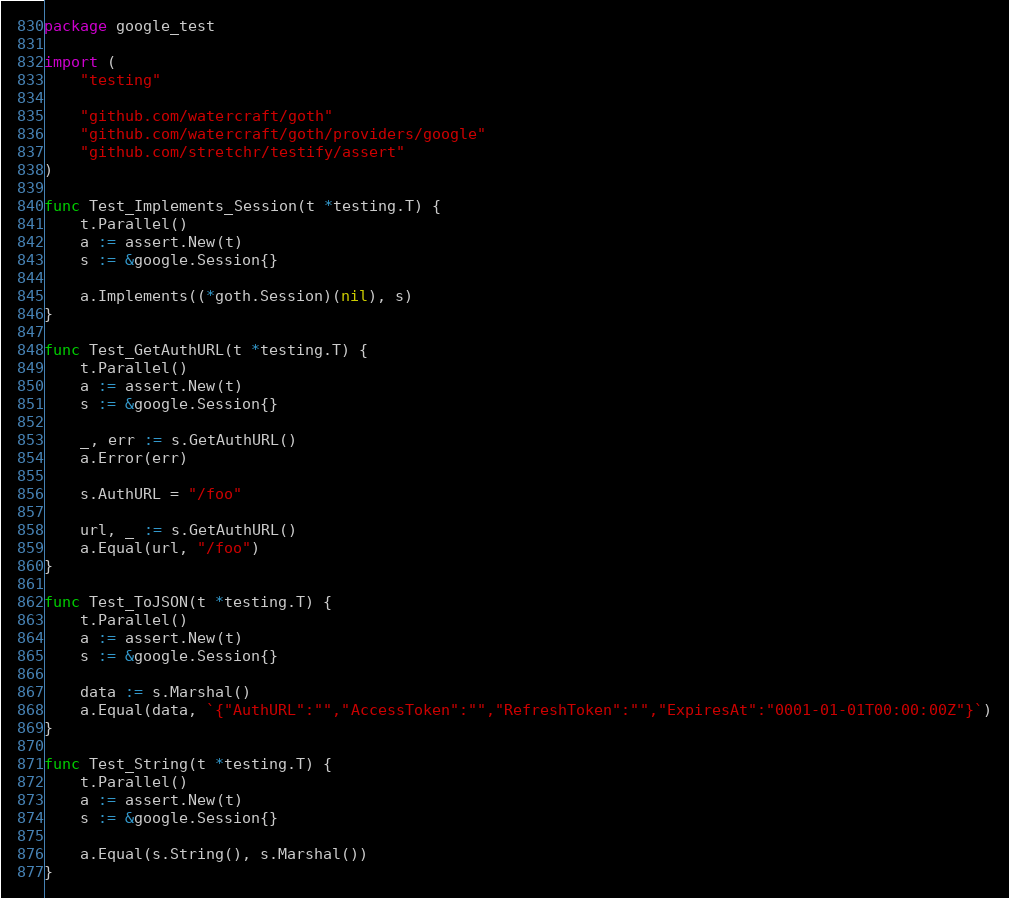<code> <loc_0><loc_0><loc_500><loc_500><_Go_>package google_test

import (
	"testing"

	"github.com/watercraft/goth"
	"github.com/watercraft/goth/providers/google"
	"github.com/stretchr/testify/assert"
)

func Test_Implements_Session(t *testing.T) {
	t.Parallel()
	a := assert.New(t)
	s := &google.Session{}

	a.Implements((*goth.Session)(nil), s)
}

func Test_GetAuthURL(t *testing.T) {
	t.Parallel()
	a := assert.New(t)
	s := &google.Session{}

	_, err := s.GetAuthURL()
	a.Error(err)

	s.AuthURL = "/foo"

	url, _ := s.GetAuthURL()
	a.Equal(url, "/foo")
}

func Test_ToJSON(t *testing.T) {
	t.Parallel()
	a := assert.New(t)
	s := &google.Session{}

	data := s.Marshal()
	a.Equal(data, `{"AuthURL":"","AccessToken":"","RefreshToken":"","ExpiresAt":"0001-01-01T00:00:00Z"}`)
}

func Test_String(t *testing.T) {
	t.Parallel()
	a := assert.New(t)
	s := &google.Session{}

	a.Equal(s.String(), s.Marshal())
}
</code> 